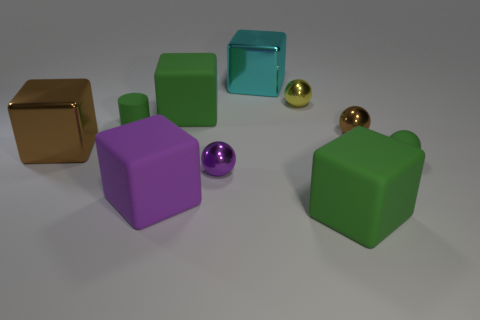Are the big cyan cube and the green cube in front of the tiny green sphere made of the same material?
Give a very brief answer. No. There is a small object that is the same color as the matte sphere; what material is it?
Provide a succinct answer. Rubber. What number of small matte spheres are the same color as the cylinder?
Give a very brief answer. 1. What size is the green matte sphere?
Ensure brevity in your answer.  Small. Is the shape of the small purple metal thing the same as the tiny green thing that is to the right of the small yellow object?
Your answer should be compact. Yes. There is a ball that is made of the same material as the cylinder; what color is it?
Provide a short and direct response. Green. How big is the brown thing that is to the left of the cyan thing?
Offer a very short reply. Large. Is the number of purple cubes that are on the right side of the brown ball less than the number of large metal blocks?
Make the answer very short. Yes. Do the cylinder and the small rubber sphere have the same color?
Ensure brevity in your answer.  Yes. Is there anything else that has the same shape as the tiny yellow object?
Keep it short and to the point. Yes. 